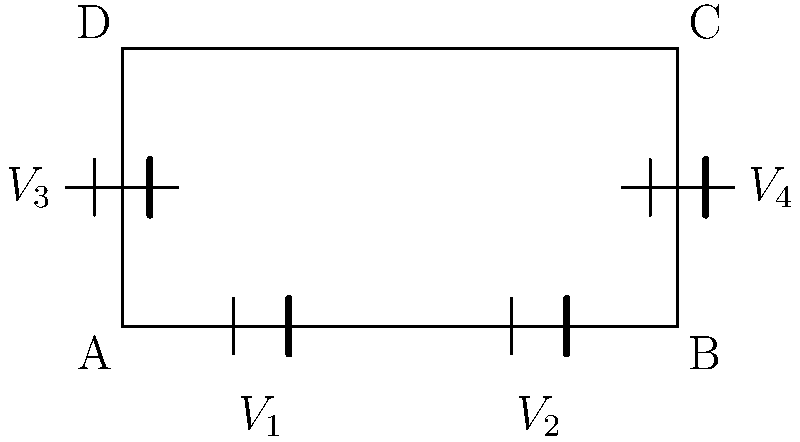In the series-parallel battery configuration shown, batteries $V_1$ and $V_2$ are connected in series, as are $V_3$ and $V_4$. These two series combinations are then connected in parallel. If $V_1 = 12V$, $V_2 = 12V$, $V_3 = 11V$, and $V_4 = 13V$, what is the voltage difference between points A and C in the circuit? To solve this problem, we'll follow these steps:

1) First, calculate the total voltage for each series combination:
   - Series combination 1 (bottom): $V_{bottom} = V_1 + V_2 = 12V + 12V = 24V$
   - Series combination 2 (side): $V_{side} = V_3 + V_4 = 11V + 13V = 24V$

2) In a parallel connection, the voltage across each branch is the same. Therefore, the voltage difference between points A and C will be equal to either $V_{bottom}$ or $V_{side}$.

3) We can verify that both series combinations indeed produce the same voltage:
   $V_{bottom} = V_{side} = 24V$

4) This equality is not a coincidence. In a well-designed hybrid battery system, voltage regulation ensures that parallel branches maintain equal voltages to prevent undesirable current flow between branches.

5) Therefore, the voltage difference between points A and C is 24V.
Answer: 24V 